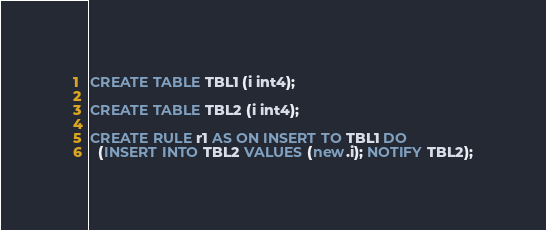<code> <loc_0><loc_0><loc_500><loc_500><_SQL_>CREATE TABLE TBL1 (i int4);

CREATE TABLE TBL2 (i int4);

CREATE RULE r1 AS ON INSERT TO TBL1 DO
  (INSERT INTO TBL2 VALUES (new.i); NOTIFY TBL2);
</code> 